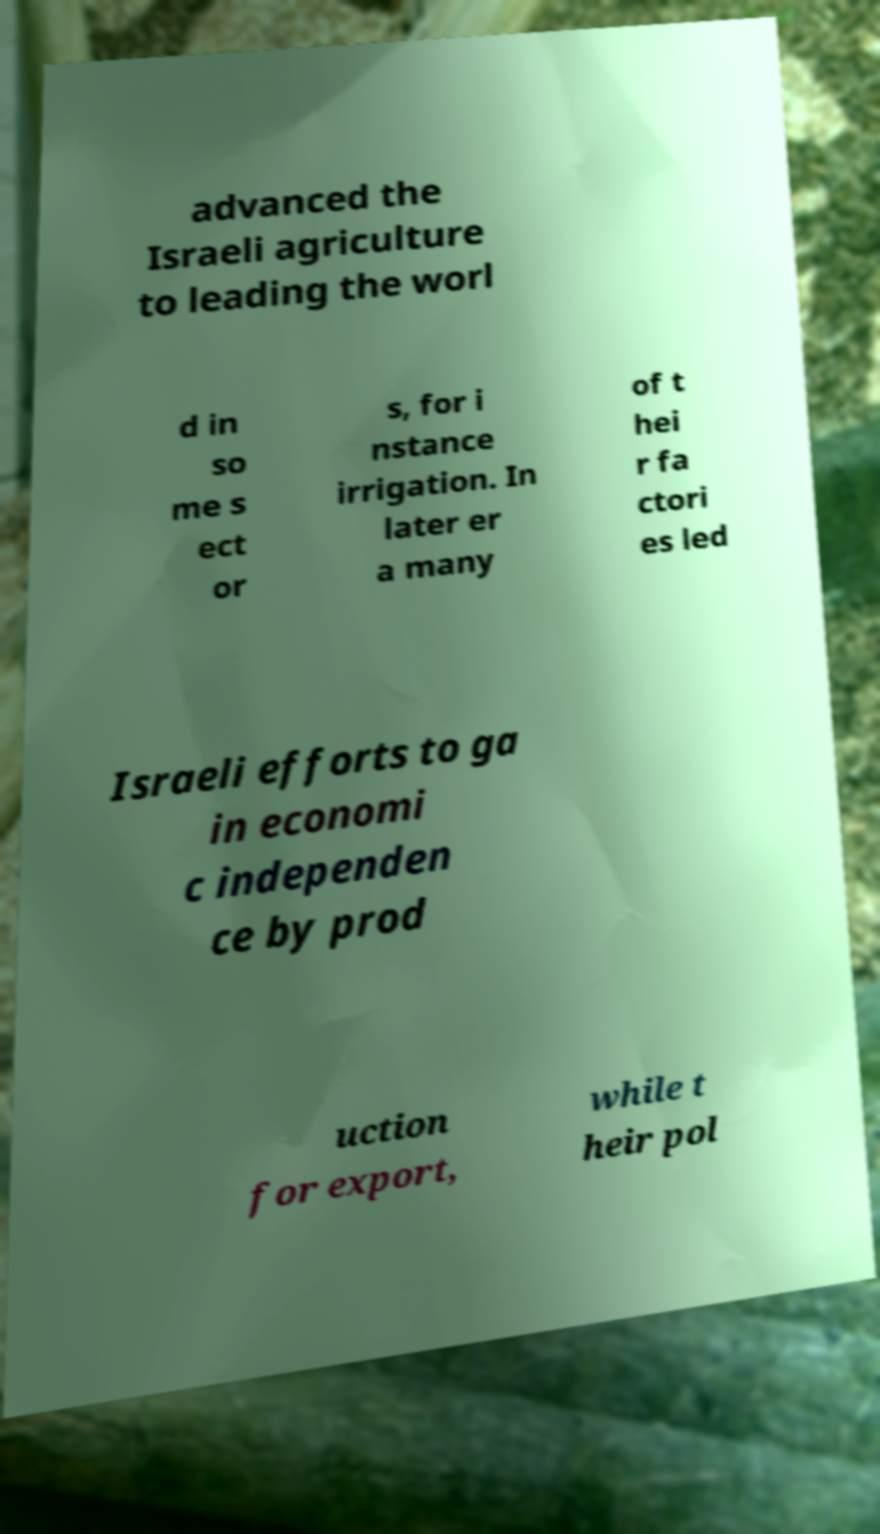What messages or text are displayed in this image? I need them in a readable, typed format. advanced the Israeli agriculture to leading the worl d in so me s ect or s, for i nstance irrigation. In later er a many of t hei r fa ctori es led Israeli efforts to ga in economi c independen ce by prod uction for export, while t heir pol 